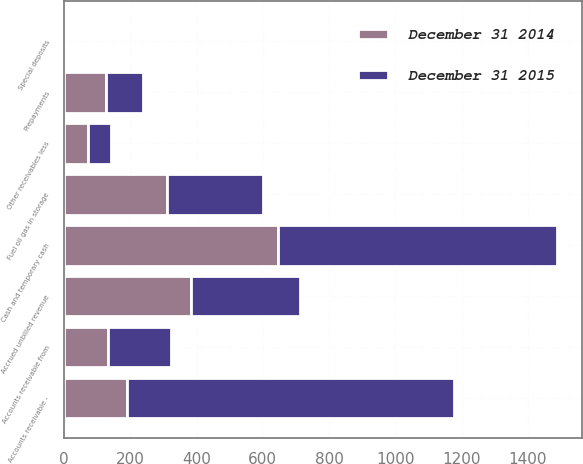Convert chart. <chart><loc_0><loc_0><loc_500><loc_500><stacked_bar_chart><ecel><fcel>Cash and temporary cash<fcel>Special deposits<fcel>Accounts receivable -<fcel>Other receivables less<fcel>Accrued unbilled revenue<fcel>Accounts receivable from<fcel>Fuel oil gas in storage<fcel>Prepayments<nl><fcel>December 31 2015<fcel>843<fcel>2<fcel>987<fcel>70<fcel>327<fcel>190<fcel>288<fcel>113<nl><fcel>December 31 2014<fcel>645<fcel>2<fcel>190<fcel>71<fcel>384<fcel>132<fcel>312<fcel>126<nl></chart> 